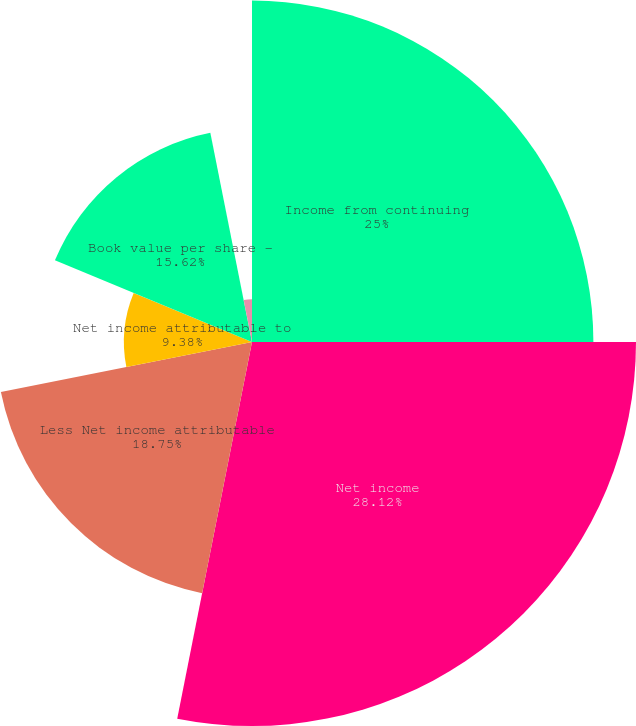Convert chart. <chart><loc_0><loc_0><loc_500><loc_500><pie_chart><fcel>Income from continuing<fcel>Net income<fcel>Less Net income attributable<fcel>Net income attributable to<fcel>Book value per share -<fcel>Continuing operations<fcel>Dividends declared per share<nl><fcel>25.0%<fcel>28.12%<fcel>18.75%<fcel>9.38%<fcel>15.62%<fcel>3.13%<fcel>0.0%<nl></chart> 